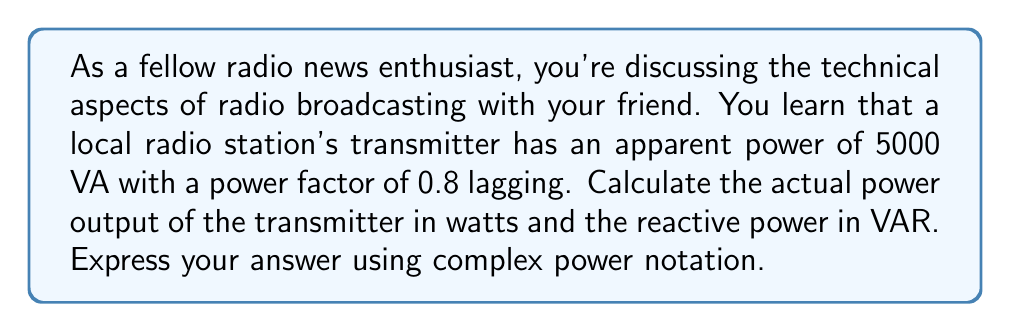Help me with this question. To solve this problem, we'll use complex power calculations. The complex power $S$ is composed of real power $P$ (measured in watts) and reactive power $Q$ (measured in volt-amperes reactive or VAR).

1) First, let's recall the formula for complex power:
   $$ S = P + jQ $$
   where $j$ is the imaginary unit.

2) We're given the apparent power $|S| = 5000$ VA and the power factor $\cos\theta = 0.8$ lagging.

3) The power factor angle $\theta$ can be calculated as:
   $$ \theta = \arccos(0.8) \approx 36.87^\circ $$

4) The real power $P$ is the apparent power multiplied by the power factor:
   $$ P = |S| \cos\theta = 5000 \cdot 0.8 = 4000 \text{ W} $$

5) The reactive power $Q$ can be calculated using the Pythagorean theorem:
   $$ Q = |S| \sin\theta = \sqrt{|S|^2 - P^2} = \sqrt{5000^2 - 4000^2} = 3000 \text{ VAR} $$

6) Since the power factor is lagging, the reactive power is positive.

7) Therefore, the complex power is:
   $$ S = 4000 + j3000 \text{ VA} $$

This means the actual power output of the transmitter is 4000 W, and the reactive power is 3000 VAR.
Answer: $S = 4000 + j3000 \text{ VA}$ 